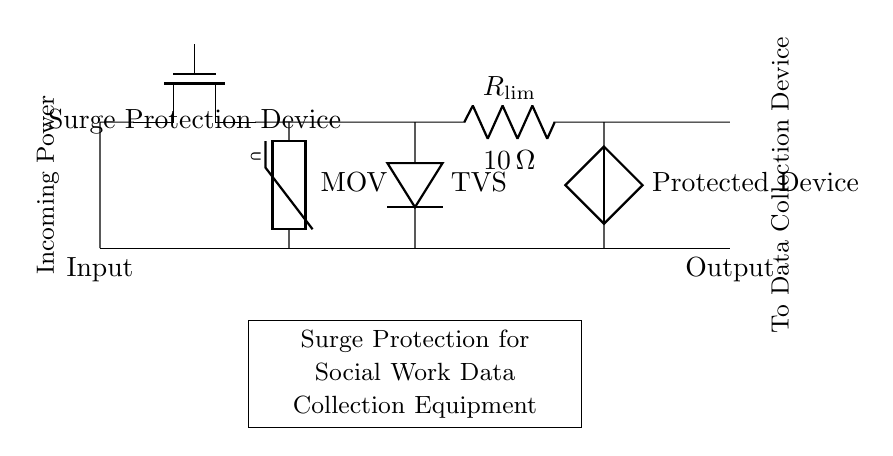What is the main function of the device labeled "Surge Protection Device"? The Surge Protection Device's main function is to divert excess voltage away from sensitive components, protecting them from damage due to surges.
Answer: Surge diversion What component limits the current in the circuit, and what is its resistance value? The component that limits the current is a resistor labeled R_lim, with a resistance value of 10 ohms, which can restrict the flow of excess current during a surge.
Answer: 10 ohms What type of circuit protection does the MOV provide? The MOV (Metal Oxide Varistor) provides over-voltage protection by clamping voltage spikes and thus protecting downstream components from high voltage surges.
Answer: Over-voltage protection How many primary components are directly involved in protecting the connected device? There are three primary components directly involved in protecting the connected device: the Surge Protection Device, the MOV, and the TVS diode.
Answer: Three components What is the role of the TVS in this circuit? The role of the TVS (Transient Voltage Suppressor) is to clamp voltage spikes and protect the circuit from transient events, ensuring the connected device operates safely under high-voltage conditions.
Answer: Transient clamping What happens to the output during a surge event? During a surge event, the protected device might experience the clamping action of the MOV and TVS, which will reduce the voltage seen at the output, helping to maintain a safe level for the connected device.
Answer: Output voltage reduction 